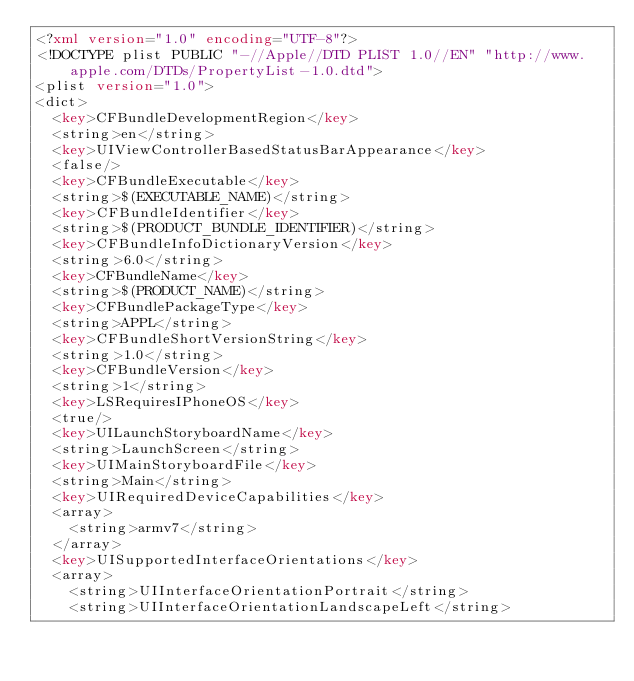<code> <loc_0><loc_0><loc_500><loc_500><_XML_><?xml version="1.0" encoding="UTF-8"?>
<!DOCTYPE plist PUBLIC "-//Apple//DTD PLIST 1.0//EN" "http://www.apple.com/DTDs/PropertyList-1.0.dtd">
<plist version="1.0">
<dict>
	<key>CFBundleDevelopmentRegion</key>
	<string>en</string>
	<key>UIViewControllerBasedStatusBarAppearance</key>
	<false/>
	<key>CFBundleExecutable</key>
	<string>$(EXECUTABLE_NAME)</string>
	<key>CFBundleIdentifier</key>
	<string>$(PRODUCT_BUNDLE_IDENTIFIER)</string>
	<key>CFBundleInfoDictionaryVersion</key>
	<string>6.0</string>
	<key>CFBundleName</key>
	<string>$(PRODUCT_NAME)</string>
	<key>CFBundlePackageType</key>
	<string>APPL</string>
	<key>CFBundleShortVersionString</key>
	<string>1.0</string>
	<key>CFBundleVersion</key>
	<string>1</string>
	<key>LSRequiresIPhoneOS</key>
	<true/>
	<key>UILaunchStoryboardName</key>
	<string>LaunchScreen</string>
	<key>UIMainStoryboardFile</key>
	<string>Main</string>
	<key>UIRequiredDeviceCapabilities</key>
	<array>
		<string>armv7</string>
	</array>
	<key>UISupportedInterfaceOrientations</key>
	<array>
		<string>UIInterfaceOrientationPortrait</string>
		<string>UIInterfaceOrientationLandscapeLeft</string></code> 